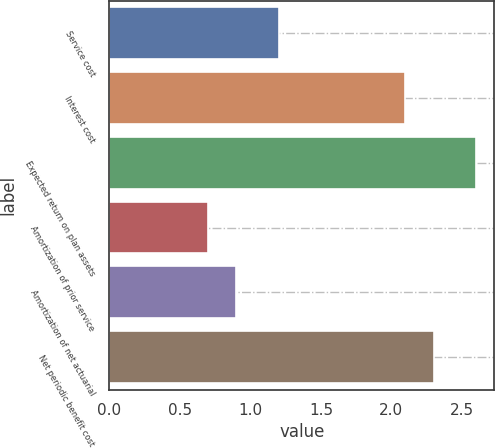<chart> <loc_0><loc_0><loc_500><loc_500><bar_chart><fcel>Service cost<fcel>Interest cost<fcel>Expected return on plan assets<fcel>Amortization of prior service<fcel>Amortization of net actuarial<fcel>Net periodic benefit cost<nl><fcel>1.2<fcel>2.1<fcel>2.6<fcel>0.7<fcel>0.9<fcel>2.3<nl></chart> 